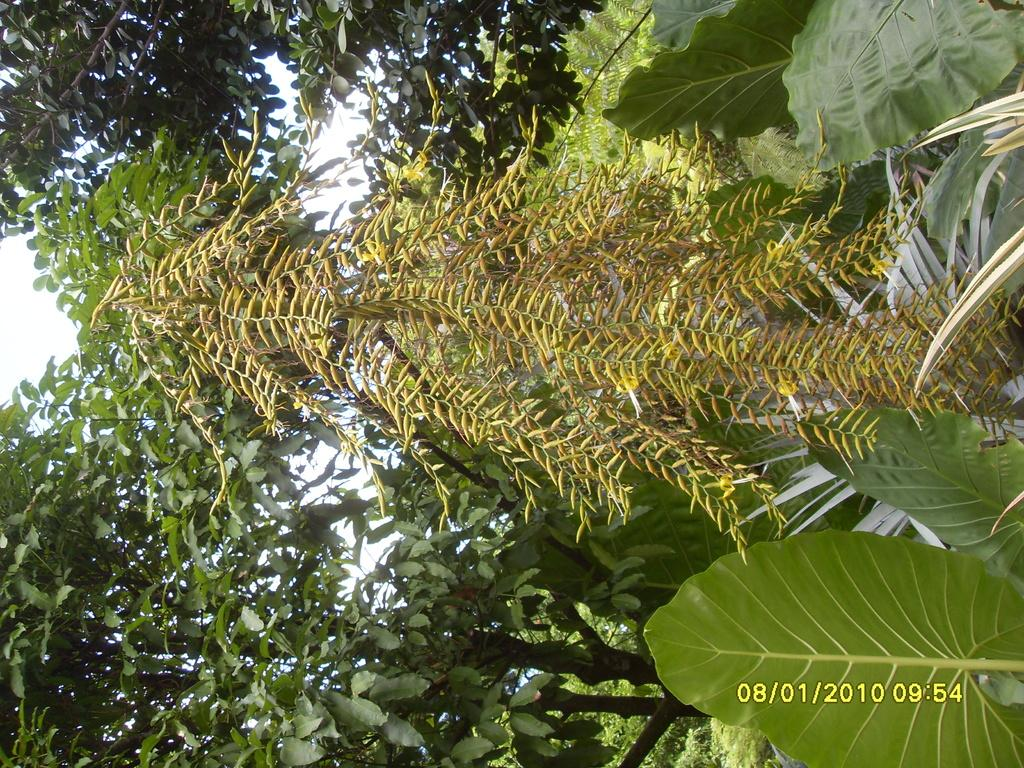What type of vegetation can be seen in the image? There is a group of trees in the image. What can be seen in the background of the image? The sky is visible in the background of the image. What type of fruit is hanging from the trees in the image? There is no fruit visible on the trees in the image. Can you see any fingers playing an instrument in the image? There are no fingers or instruments present in the image. 